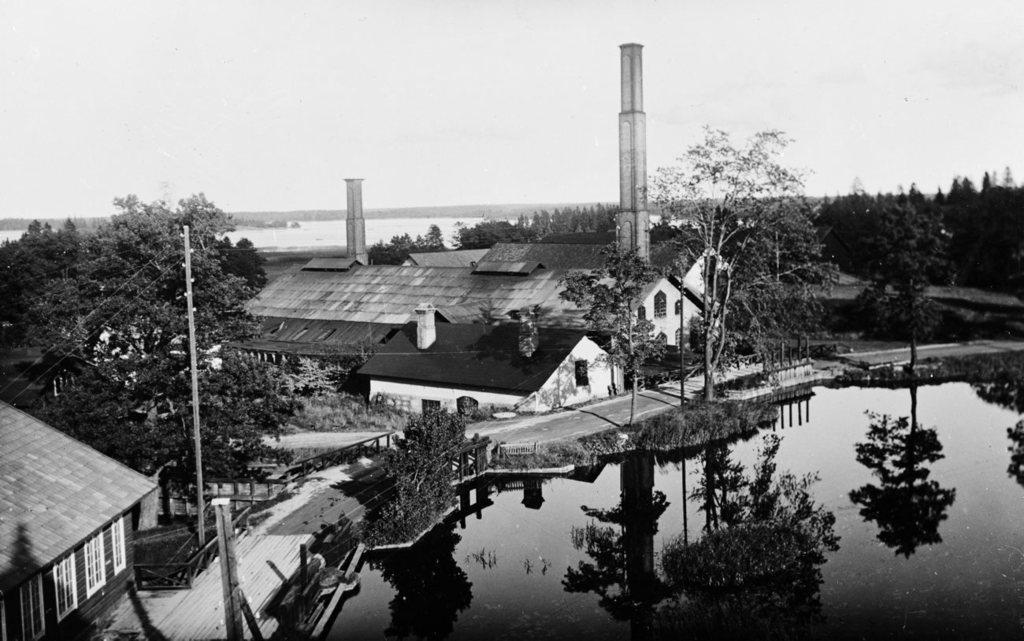In one or two sentences, can you explain what this image depicts? There are houses and trees, this is water and a sky. 